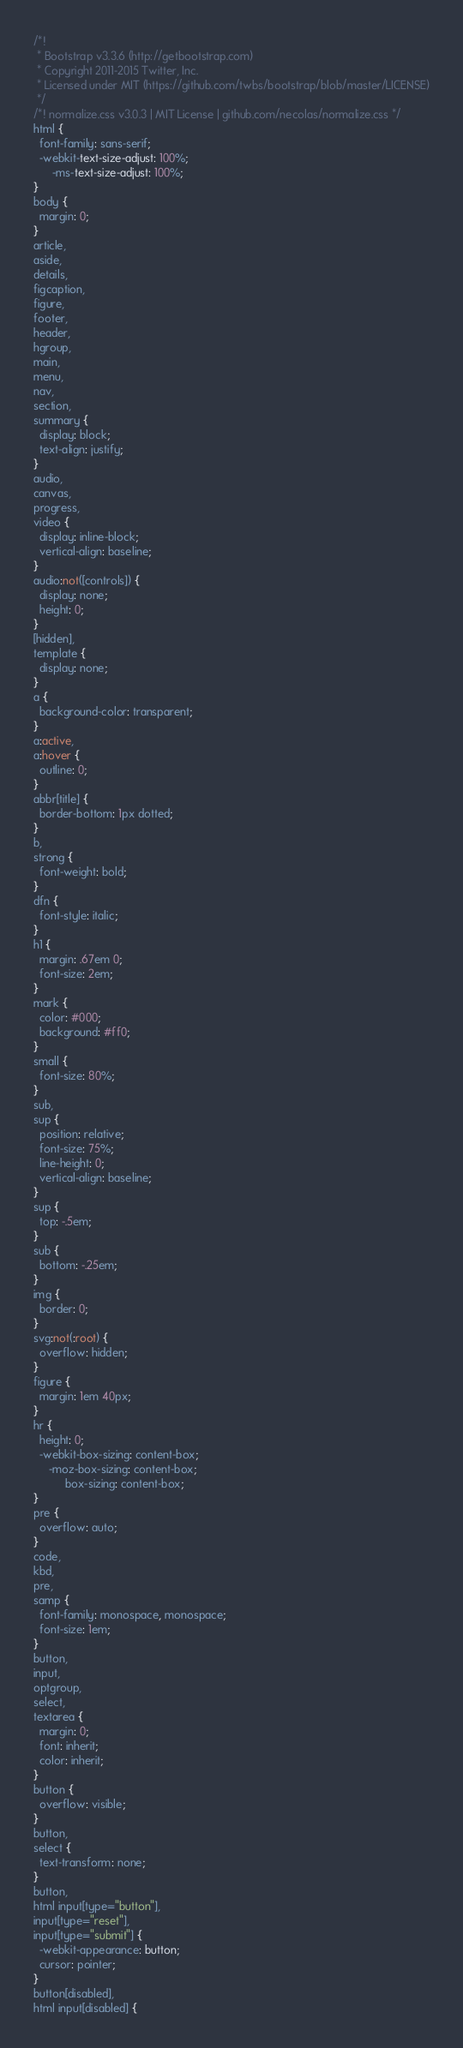<code> <loc_0><loc_0><loc_500><loc_500><_CSS_>/*!
 * Bootstrap v3.3.6 (http://getbootstrap.com)
 * Copyright 2011-2015 Twitter, Inc.
 * Licensed under MIT (https://github.com/twbs/bootstrap/blob/master/LICENSE)
 */
/*! normalize.css v3.0.3 | MIT License | github.com/necolas/normalize.css */
html {
  font-family: sans-serif;
  -webkit-text-size-adjust: 100%;
      -ms-text-size-adjust: 100%;
}
body {
  margin: 0;
}
article,
aside,
details,
figcaption,
figure,
footer,
header,
hgroup,
main,
menu,
nav,
section,
summary {
  display: block;
  text-align: justify;
}
audio,
canvas,
progress,
video {
  display: inline-block;
  vertical-align: baseline;
}
audio:not([controls]) {
  display: none;
  height: 0;
}
[hidden],
template {
  display: none;
}
a {
  background-color: transparent;
}
a:active,
a:hover {
  outline: 0;
}
abbr[title] {
  border-bottom: 1px dotted;
}
b,
strong {
  font-weight: bold;
}
dfn {
  font-style: italic;
}
h1 {
  margin: .67em 0;
  font-size: 2em;
}
mark {
  color: #000;
  background: #ff0;
}
small {
  font-size: 80%;
}
sub,
sup {
  position: relative;
  font-size: 75%;
  line-height: 0;
  vertical-align: baseline;
}
sup {
  top: -.5em;
}
sub {
  bottom: -.25em;
}
img {
  border: 0;
}
svg:not(:root) {
  overflow: hidden;
}
figure {
  margin: 1em 40px;
}
hr {
  height: 0;
  -webkit-box-sizing: content-box;
     -moz-box-sizing: content-box;
          box-sizing: content-box;
}
pre {
  overflow: auto;
}
code,
kbd,
pre,
samp {
  font-family: monospace, monospace;
  font-size: 1em;
}
button,
input,
optgroup,
select,
textarea {
  margin: 0;
  font: inherit;
  color: inherit;
}
button {
  overflow: visible;
}
button,
select {
  text-transform: none;
}
button,
html input[type="button"],
input[type="reset"],
input[type="submit"] {
  -webkit-appearance: button;
  cursor: pointer;
}
button[disabled],
html input[disabled] {</code> 